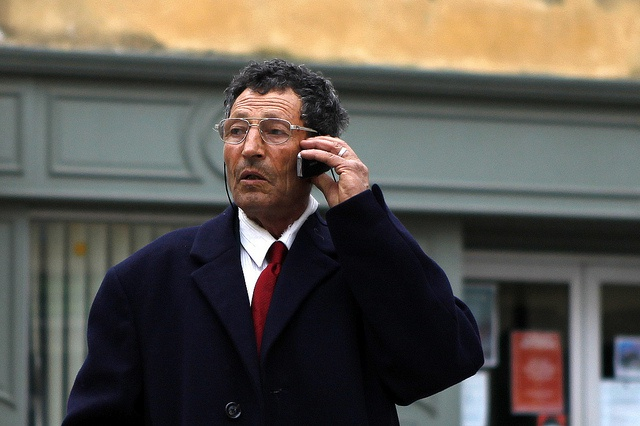Describe the objects in this image and their specific colors. I can see people in gray, black, maroon, and brown tones, tie in gray, maroon, black, and brown tones, and cell phone in gray, black, and white tones in this image. 